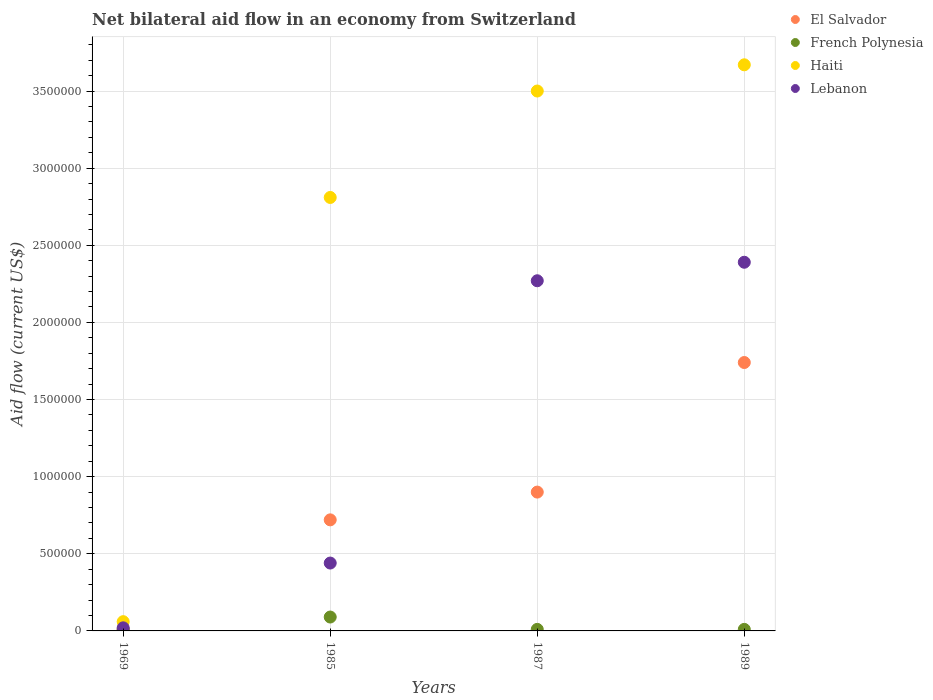Is the number of dotlines equal to the number of legend labels?
Your response must be concise. Yes. Across all years, what is the maximum net bilateral aid flow in Haiti?
Offer a very short reply. 3.67e+06. Across all years, what is the minimum net bilateral aid flow in Lebanon?
Offer a very short reply. 2.00e+04. In which year was the net bilateral aid flow in Haiti maximum?
Offer a very short reply. 1989. In which year was the net bilateral aid flow in French Polynesia minimum?
Your response must be concise. 1969. What is the total net bilateral aid flow in Lebanon in the graph?
Provide a short and direct response. 5.12e+06. What is the difference between the net bilateral aid flow in Haiti in 1989 and the net bilateral aid flow in French Polynesia in 1987?
Offer a very short reply. 3.66e+06. What is the average net bilateral aid flow in El Salvador per year?
Keep it short and to the point. 8.42e+05. What is the ratio of the net bilateral aid flow in French Polynesia in 1969 to that in 1985?
Ensure brevity in your answer.  0.11. Is the net bilateral aid flow in French Polynesia in 1985 less than that in 1989?
Provide a short and direct response. No. What is the difference between the highest and the second highest net bilateral aid flow in Lebanon?
Your response must be concise. 1.20e+05. What is the difference between the highest and the lowest net bilateral aid flow in Haiti?
Give a very brief answer. 3.61e+06. In how many years, is the net bilateral aid flow in Haiti greater than the average net bilateral aid flow in Haiti taken over all years?
Keep it short and to the point. 3. Is it the case that in every year, the sum of the net bilateral aid flow in Lebanon and net bilateral aid flow in Haiti  is greater than the sum of net bilateral aid flow in French Polynesia and net bilateral aid flow in El Salvador?
Provide a short and direct response. Yes. Where does the legend appear in the graph?
Give a very brief answer. Top right. How many legend labels are there?
Your answer should be compact. 4. How are the legend labels stacked?
Ensure brevity in your answer.  Vertical. What is the title of the graph?
Offer a very short reply. Net bilateral aid flow in an economy from Switzerland. What is the label or title of the Y-axis?
Offer a terse response. Aid flow (current US$). What is the Aid flow (current US$) of El Salvador in 1969?
Offer a terse response. 10000. What is the Aid flow (current US$) in Lebanon in 1969?
Keep it short and to the point. 2.00e+04. What is the Aid flow (current US$) of El Salvador in 1985?
Offer a terse response. 7.20e+05. What is the Aid flow (current US$) in French Polynesia in 1985?
Provide a short and direct response. 9.00e+04. What is the Aid flow (current US$) in Haiti in 1985?
Ensure brevity in your answer.  2.81e+06. What is the Aid flow (current US$) in Lebanon in 1985?
Your answer should be compact. 4.40e+05. What is the Aid flow (current US$) in Haiti in 1987?
Ensure brevity in your answer.  3.50e+06. What is the Aid flow (current US$) of Lebanon in 1987?
Offer a terse response. 2.27e+06. What is the Aid flow (current US$) of El Salvador in 1989?
Give a very brief answer. 1.74e+06. What is the Aid flow (current US$) in Haiti in 1989?
Your answer should be compact. 3.67e+06. What is the Aid flow (current US$) of Lebanon in 1989?
Offer a very short reply. 2.39e+06. Across all years, what is the maximum Aid flow (current US$) of El Salvador?
Make the answer very short. 1.74e+06. Across all years, what is the maximum Aid flow (current US$) in French Polynesia?
Offer a very short reply. 9.00e+04. Across all years, what is the maximum Aid flow (current US$) of Haiti?
Your answer should be very brief. 3.67e+06. Across all years, what is the maximum Aid flow (current US$) in Lebanon?
Provide a short and direct response. 2.39e+06. What is the total Aid flow (current US$) of El Salvador in the graph?
Provide a short and direct response. 3.37e+06. What is the total Aid flow (current US$) of Haiti in the graph?
Keep it short and to the point. 1.00e+07. What is the total Aid flow (current US$) of Lebanon in the graph?
Your response must be concise. 5.12e+06. What is the difference between the Aid flow (current US$) in El Salvador in 1969 and that in 1985?
Make the answer very short. -7.10e+05. What is the difference between the Aid flow (current US$) in Haiti in 1969 and that in 1985?
Provide a succinct answer. -2.75e+06. What is the difference between the Aid flow (current US$) of Lebanon in 1969 and that in 1985?
Offer a very short reply. -4.20e+05. What is the difference between the Aid flow (current US$) in El Salvador in 1969 and that in 1987?
Give a very brief answer. -8.90e+05. What is the difference between the Aid flow (current US$) of French Polynesia in 1969 and that in 1987?
Provide a short and direct response. 0. What is the difference between the Aid flow (current US$) of Haiti in 1969 and that in 1987?
Make the answer very short. -3.44e+06. What is the difference between the Aid flow (current US$) in Lebanon in 1969 and that in 1987?
Your answer should be compact. -2.25e+06. What is the difference between the Aid flow (current US$) of El Salvador in 1969 and that in 1989?
Provide a short and direct response. -1.73e+06. What is the difference between the Aid flow (current US$) of Haiti in 1969 and that in 1989?
Offer a very short reply. -3.61e+06. What is the difference between the Aid flow (current US$) in Lebanon in 1969 and that in 1989?
Offer a terse response. -2.37e+06. What is the difference between the Aid flow (current US$) of El Salvador in 1985 and that in 1987?
Provide a succinct answer. -1.80e+05. What is the difference between the Aid flow (current US$) of French Polynesia in 1985 and that in 1987?
Your answer should be compact. 8.00e+04. What is the difference between the Aid flow (current US$) of Haiti in 1985 and that in 1987?
Your response must be concise. -6.90e+05. What is the difference between the Aid flow (current US$) of Lebanon in 1985 and that in 1987?
Provide a short and direct response. -1.83e+06. What is the difference between the Aid flow (current US$) in El Salvador in 1985 and that in 1989?
Offer a very short reply. -1.02e+06. What is the difference between the Aid flow (current US$) in French Polynesia in 1985 and that in 1989?
Your answer should be compact. 8.00e+04. What is the difference between the Aid flow (current US$) in Haiti in 1985 and that in 1989?
Provide a short and direct response. -8.60e+05. What is the difference between the Aid flow (current US$) in Lebanon in 1985 and that in 1989?
Offer a terse response. -1.95e+06. What is the difference between the Aid flow (current US$) of El Salvador in 1987 and that in 1989?
Provide a succinct answer. -8.40e+05. What is the difference between the Aid flow (current US$) in French Polynesia in 1987 and that in 1989?
Make the answer very short. 0. What is the difference between the Aid flow (current US$) in El Salvador in 1969 and the Aid flow (current US$) in Haiti in 1985?
Keep it short and to the point. -2.80e+06. What is the difference between the Aid flow (current US$) of El Salvador in 1969 and the Aid flow (current US$) of Lebanon in 1985?
Provide a short and direct response. -4.30e+05. What is the difference between the Aid flow (current US$) of French Polynesia in 1969 and the Aid flow (current US$) of Haiti in 1985?
Offer a very short reply. -2.80e+06. What is the difference between the Aid flow (current US$) of French Polynesia in 1969 and the Aid flow (current US$) of Lebanon in 1985?
Provide a short and direct response. -4.30e+05. What is the difference between the Aid flow (current US$) of Haiti in 1969 and the Aid flow (current US$) of Lebanon in 1985?
Your answer should be very brief. -3.80e+05. What is the difference between the Aid flow (current US$) of El Salvador in 1969 and the Aid flow (current US$) of French Polynesia in 1987?
Your answer should be very brief. 0. What is the difference between the Aid flow (current US$) in El Salvador in 1969 and the Aid flow (current US$) in Haiti in 1987?
Offer a terse response. -3.49e+06. What is the difference between the Aid flow (current US$) of El Salvador in 1969 and the Aid flow (current US$) of Lebanon in 1987?
Ensure brevity in your answer.  -2.26e+06. What is the difference between the Aid flow (current US$) in French Polynesia in 1969 and the Aid flow (current US$) in Haiti in 1987?
Make the answer very short. -3.49e+06. What is the difference between the Aid flow (current US$) of French Polynesia in 1969 and the Aid flow (current US$) of Lebanon in 1987?
Offer a very short reply. -2.26e+06. What is the difference between the Aid flow (current US$) in Haiti in 1969 and the Aid flow (current US$) in Lebanon in 1987?
Ensure brevity in your answer.  -2.21e+06. What is the difference between the Aid flow (current US$) in El Salvador in 1969 and the Aid flow (current US$) in Haiti in 1989?
Offer a very short reply. -3.66e+06. What is the difference between the Aid flow (current US$) in El Salvador in 1969 and the Aid flow (current US$) in Lebanon in 1989?
Your answer should be very brief. -2.38e+06. What is the difference between the Aid flow (current US$) of French Polynesia in 1969 and the Aid flow (current US$) of Haiti in 1989?
Provide a succinct answer. -3.66e+06. What is the difference between the Aid flow (current US$) of French Polynesia in 1969 and the Aid flow (current US$) of Lebanon in 1989?
Make the answer very short. -2.38e+06. What is the difference between the Aid flow (current US$) of Haiti in 1969 and the Aid flow (current US$) of Lebanon in 1989?
Ensure brevity in your answer.  -2.33e+06. What is the difference between the Aid flow (current US$) in El Salvador in 1985 and the Aid flow (current US$) in French Polynesia in 1987?
Offer a very short reply. 7.10e+05. What is the difference between the Aid flow (current US$) in El Salvador in 1985 and the Aid flow (current US$) in Haiti in 1987?
Ensure brevity in your answer.  -2.78e+06. What is the difference between the Aid flow (current US$) in El Salvador in 1985 and the Aid flow (current US$) in Lebanon in 1987?
Give a very brief answer. -1.55e+06. What is the difference between the Aid flow (current US$) in French Polynesia in 1985 and the Aid flow (current US$) in Haiti in 1987?
Your answer should be compact. -3.41e+06. What is the difference between the Aid flow (current US$) in French Polynesia in 1985 and the Aid flow (current US$) in Lebanon in 1987?
Ensure brevity in your answer.  -2.18e+06. What is the difference between the Aid flow (current US$) of Haiti in 1985 and the Aid flow (current US$) of Lebanon in 1987?
Your answer should be very brief. 5.40e+05. What is the difference between the Aid flow (current US$) of El Salvador in 1985 and the Aid flow (current US$) of French Polynesia in 1989?
Keep it short and to the point. 7.10e+05. What is the difference between the Aid flow (current US$) in El Salvador in 1985 and the Aid flow (current US$) in Haiti in 1989?
Provide a succinct answer. -2.95e+06. What is the difference between the Aid flow (current US$) in El Salvador in 1985 and the Aid flow (current US$) in Lebanon in 1989?
Your response must be concise. -1.67e+06. What is the difference between the Aid flow (current US$) in French Polynesia in 1985 and the Aid flow (current US$) in Haiti in 1989?
Give a very brief answer. -3.58e+06. What is the difference between the Aid flow (current US$) in French Polynesia in 1985 and the Aid flow (current US$) in Lebanon in 1989?
Give a very brief answer. -2.30e+06. What is the difference between the Aid flow (current US$) in Haiti in 1985 and the Aid flow (current US$) in Lebanon in 1989?
Keep it short and to the point. 4.20e+05. What is the difference between the Aid flow (current US$) of El Salvador in 1987 and the Aid flow (current US$) of French Polynesia in 1989?
Provide a short and direct response. 8.90e+05. What is the difference between the Aid flow (current US$) in El Salvador in 1987 and the Aid flow (current US$) in Haiti in 1989?
Offer a very short reply. -2.77e+06. What is the difference between the Aid flow (current US$) in El Salvador in 1987 and the Aid flow (current US$) in Lebanon in 1989?
Provide a short and direct response. -1.49e+06. What is the difference between the Aid flow (current US$) in French Polynesia in 1987 and the Aid flow (current US$) in Haiti in 1989?
Provide a short and direct response. -3.66e+06. What is the difference between the Aid flow (current US$) of French Polynesia in 1987 and the Aid flow (current US$) of Lebanon in 1989?
Ensure brevity in your answer.  -2.38e+06. What is the difference between the Aid flow (current US$) of Haiti in 1987 and the Aid flow (current US$) of Lebanon in 1989?
Keep it short and to the point. 1.11e+06. What is the average Aid flow (current US$) in El Salvador per year?
Provide a short and direct response. 8.42e+05. What is the average Aid flow (current US$) of French Polynesia per year?
Keep it short and to the point. 3.00e+04. What is the average Aid flow (current US$) of Haiti per year?
Offer a very short reply. 2.51e+06. What is the average Aid flow (current US$) in Lebanon per year?
Make the answer very short. 1.28e+06. In the year 1969, what is the difference between the Aid flow (current US$) of El Salvador and Aid flow (current US$) of French Polynesia?
Provide a succinct answer. 0. In the year 1969, what is the difference between the Aid flow (current US$) of El Salvador and Aid flow (current US$) of Haiti?
Make the answer very short. -5.00e+04. In the year 1969, what is the difference between the Aid flow (current US$) of El Salvador and Aid flow (current US$) of Lebanon?
Offer a very short reply. -10000. In the year 1969, what is the difference between the Aid flow (current US$) of French Polynesia and Aid flow (current US$) of Lebanon?
Make the answer very short. -10000. In the year 1985, what is the difference between the Aid flow (current US$) in El Salvador and Aid flow (current US$) in French Polynesia?
Your answer should be very brief. 6.30e+05. In the year 1985, what is the difference between the Aid flow (current US$) in El Salvador and Aid flow (current US$) in Haiti?
Your response must be concise. -2.09e+06. In the year 1985, what is the difference between the Aid flow (current US$) in El Salvador and Aid flow (current US$) in Lebanon?
Provide a short and direct response. 2.80e+05. In the year 1985, what is the difference between the Aid flow (current US$) in French Polynesia and Aid flow (current US$) in Haiti?
Make the answer very short. -2.72e+06. In the year 1985, what is the difference between the Aid flow (current US$) of French Polynesia and Aid flow (current US$) of Lebanon?
Keep it short and to the point. -3.50e+05. In the year 1985, what is the difference between the Aid flow (current US$) in Haiti and Aid flow (current US$) in Lebanon?
Offer a terse response. 2.37e+06. In the year 1987, what is the difference between the Aid flow (current US$) in El Salvador and Aid flow (current US$) in French Polynesia?
Offer a very short reply. 8.90e+05. In the year 1987, what is the difference between the Aid flow (current US$) of El Salvador and Aid flow (current US$) of Haiti?
Your response must be concise. -2.60e+06. In the year 1987, what is the difference between the Aid flow (current US$) in El Salvador and Aid flow (current US$) in Lebanon?
Give a very brief answer. -1.37e+06. In the year 1987, what is the difference between the Aid flow (current US$) of French Polynesia and Aid flow (current US$) of Haiti?
Offer a very short reply. -3.49e+06. In the year 1987, what is the difference between the Aid flow (current US$) in French Polynesia and Aid flow (current US$) in Lebanon?
Provide a short and direct response. -2.26e+06. In the year 1987, what is the difference between the Aid flow (current US$) of Haiti and Aid flow (current US$) of Lebanon?
Offer a terse response. 1.23e+06. In the year 1989, what is the difference between the Aid flow (current US$) of El Salvador and Aid flow (current US$) of French Polynesia?
Ensure brevity in your answer.  1.73e+06. In the year 1989, what is the difference between the Aid flow (current US$) of El Salvador and Aid flow (current US$) of Haiti?
Provide a short and direct response. -1.93e+06. In the year 1989, what is the difference between the Aid flow (current US$) of El Salvador and Aid flow (current US$) of Lebanon?
Keep it short and to the point. -6.50e+05. In the year 1989, what is the difference between the Aid flow (current US$) of French Polynesia and Aid flow (current US$) of Haiti?
Keep it short and to the point. -3.66e+06. In the year 1989, what is the difference between the Aid flow (current US$) of French Polynesia and Aid flow (current US$) of Lebanon?
Offer a very short reply. -2.38e+06. In the year 1989, what is the difference between the Aid flow (current US$) in Haiti and Aid flow (current US$) in Lebanon?
Provide a short and direct response. 1.28e+06. What is the ratio of the Aid flow (current US$) in El Salvador in 1969 to that in 1985?
Offer a terse response. 0.01. What is the ratio of the Aid flow (current US$) of Haiti in 1969 to that in 1985?
Your answer should be very brief. 0.02. What is the ratio of the Aid flow (current US$) of Lebanon in 1969 to that in 1985?
Provide a short and direct response. 0.05. What is the ratio of the Aid flow (current US$) in El Salvador in 1969 to that in 1987?
Give a very brief answer. 0.01. What is the ratio of the Aid flow (current US$) of French Polynesia in 1969 to that in 1987?
Ensure brevity in your answer.  1. What is the ratio of the Aid flow (current US$) of Haiti in 1969 to that in 1987?
Provide a short and direct response. 0.02. What is the ratio of the Aid flow (current US$) in Lebanon in 1969 to that in 1987?
Your response must be concise. 0.01. What is the ratio of the Aid flow (current US$) in El Salvador in 1969 to that in 1989?
Give a very brief answer. 0.01. What is the ratio of the Aid flow (current US$) of French Polynesia in 1969 to that in 1989?
Keep it short and to the point. 1. What is the ratio of the Aid flow (current US$) in Haiti in 1969 to that in 1989?
Your answer should be very brief. 0.02. What is the ratio of the Aid flow (current US$) of Lebanon in 1969 to that in 1989?
Offer a terse response. 0.01. What is the ratio of the Aid flow (current US$) in French Polynesia in 1985 to that in 1987?
Your response must be concise. 9. What is the ratio of the Aid flow (current US$) in Haiti in 1985 to that in 1987?
Give a very brief answer. 0.8. What is the ratio of the Aid flow (current US$) of Lebanon in 1985 to that in 1987?
Offer a very short reply. 0.19. What is the ratio of the Aid flow (current US$) in El Salvador in 1985 to that in 1989?
Keep it short and to the point. 0.41. What is the ratio of the Aid flow (current US$) of French Polynesia in 1985 to that in 1989?
Offer a terse response. 9. What is the ratio of the Aid flow (current US$) in Haiti in 1985 to that in 1989?
Your answer should be compact. 0.77. What is the ratio of the Aid flow (current US$) in Lebanon in 1985 to that in 1989?
Your response must be concise. 0.18. What is the ratio of the Aid flow (current US$) of El Salvador in 1987 to that in 1989?
Your answer should be compact. 0.52. What is the ratio of the Aid flow (current US$) in French Polynesia in 1987 to that in 1989?
Make the answer very short. 1. What is the ratio of the Aid flow (current US$) in Haiti in 1987 to that in 1989?
Ensure brevity in your answer.  0.95. What is the ratio of the Aid flow (current US$) in Lebanon in 1987 to that in 1989?
Provide a succinct answer. 0.95. What is the difference between the highest and the second highest Aid flow (current US$) of El Salvador?
Keep it short and to the point. 8.40e+05. What is the difference between the highest and the second highest Aid flow (current US$) in French Polynesia?
Make the answer very short. 8.00e+04. What is the difference between the highest and the second highest Aid flow (current US$) of Haiti?
Give a very brief answer. 1.70e+05. What is the difference between the highest and the second highest Aid flow (current US$) in Lebanon?
Keep it short and to the point. 1.20e+05. What is the difference between the highest and the lowest Aid flow (current US$) of El Salvador?
Keep it short and to the point. 1.73e+06. What is the difference between the highest and the lowest Aid flow (current US$) of French Polynesia?
Your response must be concise. 8.00e+04. What is the difference between the highest and the lowest Aid flow (current US$) of Haiti?
Provide a succinct answer. 3.61e+06. What is the difference between the highest and the lowest Aid flow (current US$) in Lebanon?
Make the answer very short. 2.37e+06. 